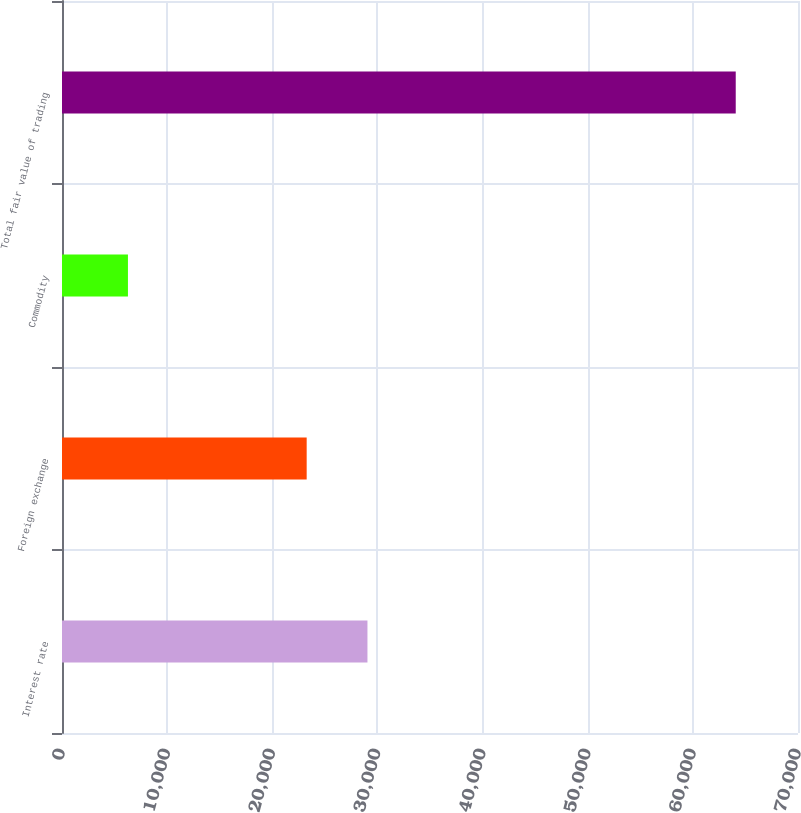Convert chart. <chart><loc_0><loc_0><loc_500><loc_500><bar_chart><fcel>Interest rate<fcel>Foreign exchange<fcel>Commodity<fcel>Total fair value of trading<nl><fcel>29051.6<fcel>23271<fcel>6272<fcel>64078<nl></chart> 